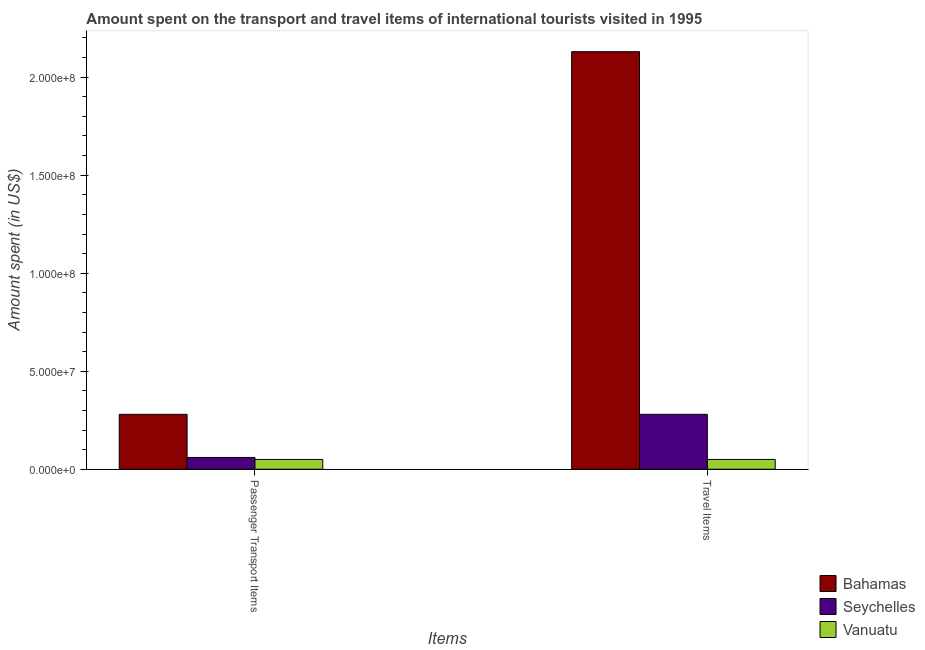How many groups of bars are there?
Your answer should be very brief. 2. Are the number of bars per tick equal to the number of legend labels?
Offer a very short reply. Yes. Are the number of bars on each tick of the X-axis equal?
Offer a terse response. Yes. How many bars are there on the 2nd tick from the right?
Provide a short and direct response. 3. What is the label of the 2nd group of bars from the left?
Ensure brevity in your answer.  Travel Items. What is the amount spent in travel items in Bahamas?
Offer a very short reply. 2.13e+08. Across all countries, what is the maximum amount spent in travel items?
Offer a very short reply. 2.13e+08. Across all countries, what is the minimum amount spent in travel items?
Your answer should be very brief. 5.00e+06. In which country was the amount spent in travel items maximum?
Provide a succinct answer. Bahamas. In which country was the amount spent in travel items minimum?
Give a very brief answer. Vanuatu. What is the total amount spent in travel items in the graph?
Make the answer very short. 2.46e+08. What is the difference between the amount spent in travel items in Seychelles and that in Bahamas?
Ensure brevity in your answer.  -1.85e+08. What is the difference between the amount spent on passenger transport items in Seychelles and the amount spent in travel items in Bahamas?
Keep it short and to the point. -2.07e+08. What is the average amount spent on passenger transport items per country?
Keep it short and to the point. 1.30e+07. What is the difference between the amount spent on passenger transport items and amount spent in travel items in Seychelles?
Provide a succinct answer. -2.20e+07. In how many countries, is the amount spent on passenger transport items greater than 90000000 US$?
Make the answer very short. 0. What is the ratio of the amount spent in travel items in Bahamas to that in Vanuatu?
Offer a very short reply. 42.6. In how many countries, is the amount spent in travel items greater than the average amount spent in travel items taken over all countries?
Your answer should be very brief. 1. What does the 3rd bar from the left in Travel Items represents?
Make the answer very short. Vanuatu. What does the 1st bar from the right in Passenger Transport Items represents?
Offer a terse response. Vanuatu. What is the difference between two consecutive major ticks on the Y-axis?
Provide a succinct answer. 5.00e+07. Does the graph contain any zero values?
Your response must be concise. No. What is the title of the graph?
Provide a short and direct response. Amount spent on the transport and travel items of international tourists visited in 1995. What is the label or title of the X-axis?
Keep it short and to the point. Items. What is the label or title of the Y-axis?
Offer a terse response. Amount spent (in US$). What is the Amount spent (in US$) of Bahamas in Passenger Transport Items?
Give a very brief answer. 2.80e+07. What is the Amount spent (in US$) in Seychelles in Passenger Transport Items?
Offer a very short reply. 6.00e+06. What is the Amount spent (in US$) in Bahamas in Travel Items?
Your answer should be compact. 2.13e+08. What is the Amount spent (in US$) of Seychelles in Travel Items?
Keep it short and to the point. 2.80e+07. Across all Items, what is the maximum Amount spent (in US$) of Bahamas?
Your answer should be very brief. 2.13e+08. Across all Items, what is the maximum Amount spent (in US$) of Seychelles?
Provide a succinct answer. 2.80e+07. Across all Items, what is the maximum Amount spent (in US$) in Vanuatu?
Make the answer very short. 5.00e+06. Across all Items, what is the minimum Amount spent (in US$) of Bahamas?
Your answer should be compact. 2.80e+07. Across all Items, what is the minimum Amount spent (in US$) in Seychelles?
Ensure brevity in your answer.  6.00e+06. Across all Items, what is the minimum Amount spent (in US$) in Vanuatu?
Ensure brevity in your answer.  5.00e+06. What is the total Amount spent (in US$) of Bahamas in the graph?
Provide a succinct answer. 2.41e+08. What is the total Amount spent (in US$) in Seychelles in the graph?
Provide a short and direct response. 3.40e+07. What is the difference between the Amount spent (in US$) of Bahamas in Passenger Transport Items and that in Travel Items?
Provide a short and direct response. -1.85e+08. What is the difference between the Amount spent (in US$) in Seychelles in Passenger Transport Items and that in Travel Items?
Provide a succinct answer. -2.20e+07. What is the difference between the Amount spent (in US$) in Vanuatu in Passenger Transport Items and that in Travel Items?
Give a very brief answer. 0. What is the difference between the Amount spent (in US$) of Bahamas in Passenger Transport Items and the Amount spent (in US$) of Vanuatu in Travel Items?
Give a very brief answer. 2.30e+07. What is the difference between the Amount spent (in US$) in Seychelles in Passenger Transport Items and the Amount spent (in US$) in Vanuatu in Travel Items?
Ensure brevity in your answer.  1.00e+06. What is the average Amount spent (in US$) in Bahamas per Items?
Make the answer very short. 1.20e+08. What is the average Amount spent (in US$) of Seychelles per Items?
Ensure brevity in your answer.  1.70e+07. What is the difference between the Amount spent (in US$) in Bahamas and Amount spent (in US$) in Seychelles in Passenger Transport Items?
Make the answer very short. 2.20e+07. What is the difference between the Amount spent (in US$) in Bahamas and Amount spent (in US$) in Vanuatu in Passenger Transport Items?
Your answer should be compact. 2.30e+07. What is the difference between the Amount spent (in US$) in Bahamas and Amount spent (in US$) in Seychelles in Travel Items?
Provide a succinct answer. 1.85e+08. What is the difference between the Amount spent (in US$) of Bahamas and Amount spent (in US$) of Vanuatu in Travel Items?
Your answer should be compact. 2.08e+08. What is the difference between the Amount spent (in US$) in Seychelles and Amount spent (in US$) in Vanuatu in Travel Items?
Your answer should be compact. 2.30e+07. What is the ratio of the Amount spent (in US$) of Bahamas in Passenger Transport Items to that in Travel Items?
Give a very brief answer. 0.13. What is the ratio of the Amount spent (in US$) in Seychelles in Passenger Transport Items to that in Travel Items?
Ensure brevity in your answer.  0.21. What is the ratio of the Amount spent (in US$) in Vanuatu in Passenger Transport Items to that in Travel Items?
Provide a succinct answer. 1. What is the difference between the highest and the second highest Amount spent (in US$) of Bahamas?
Your answer should be compact. 1.85e+08. What is the difference between the highest and the second highest Amount spent (in US$) in Seychelles?
Provide a short and direct response. 2.20e+07. What is the difference between the highest and the second highest Amount spent (in US$) in Vanuatu?
Ensure brevity in your answer.  0. What is the difference between the highest and the lowest Amount spent (in US$) of Bahamas?
Your response must be concise. 1.85e+08. What is the difference between the highest and the lowest Amount spent (in US$) in Seychelles?
Your response must be concise. 2.20e+07. What is the difference between the highest and the lowest Amount spent (in US$) in Vanuatu?
Your response must be concise. 0. 